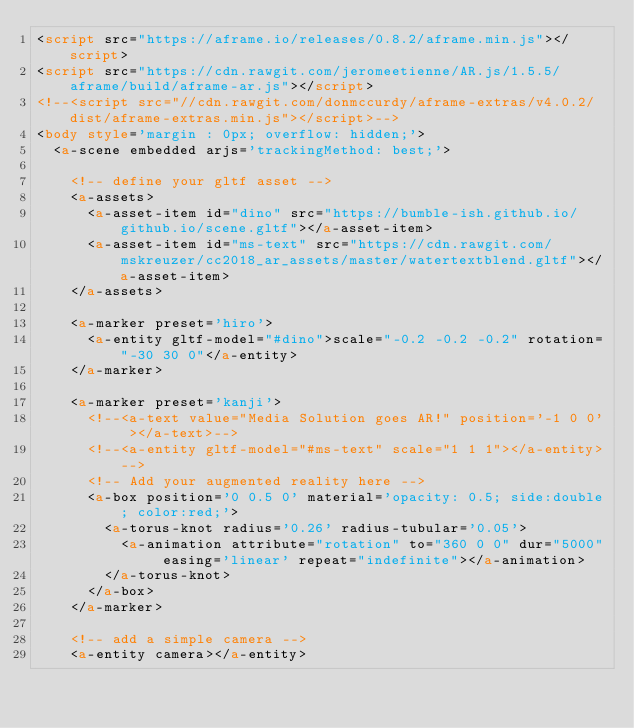<code> <loc_0><loc_0><loc_500><loc_500><_HTML_><script src="https://aframe.io/releases/0.8.2/aframe.min.js"></script>
<script src="https://cdn.rawgit.com/jeromeetienne/AR.js/1.5.5/aframe/build/aframe-ar.js"></script>
<!--<script src="//cdn.rawgit.com/donmccurdy/aframe-extras/v4.0.2/dist/aframe-extras.min.js"></script>-->
<body style='margin : 0px; overflow: hidden;'>
  <a-scene embedded arjs='trackingMethod: best;'>
    
    <!-- define your gltf asset -->
    <a-assets>
      <a-asset-item id="dino" src="https://bumble-ish.github.io/github.io/scene.gltf"></a-asset-item>
      <a-asset-item id="ms-text" src="https://cdn.rawgit.com/mskreuzer/cc2018_ar_assets/master/watertextblend.gltf"></a-asset-item>
    </a-assets> 
    
    <a-marker preset='hiro'>
      <a-entity gltf-model="#dino">scale="-0.2 -0.2 -0.2" rotation="-30 30 0"</a-entity>
    </a-marker>
    
    <a-marker preset='kanji'>
      <!--<a-text value="Media Solution goes AR!" position='-1 0 0' ></a-text>-->
      <!--<a-entity gltf-model="#ms-text" scale="1 1 1"></a-entity>-->
      <!-- Add your augmented reality here -->
			<a-box position='0 0.5 0' material='opacity: 0.5; side:double; color:red;'>
				<a-torus-knot radius='0.26' radius-tubular='0.05'>
					<a-animation attribute="rotation" to="360 0 0" dur="5000" easing='linear' repeat="indefinite"></a-animation>
				</a-torus-knot>
      </a-box>
    </a-marker>
    
    <!-- add a simple camera -->
    <a-entity camera></a-entity></code> 